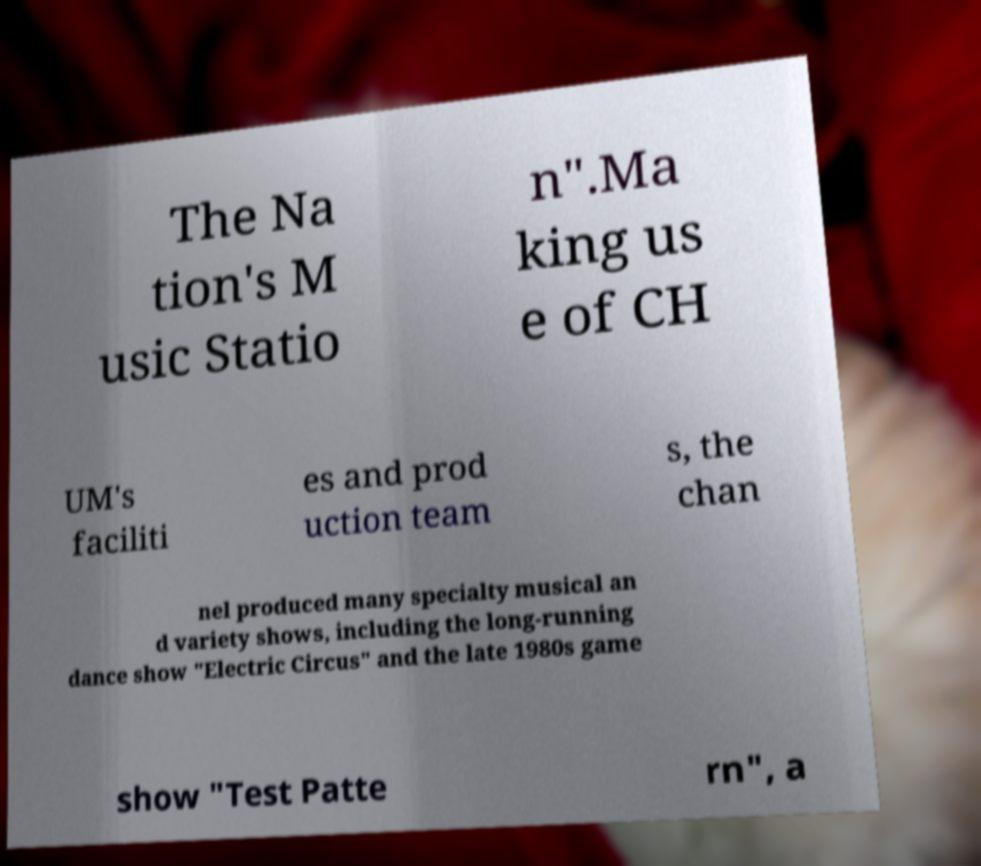There's text embedded in this image that I need extracted. Can you transcribe it verbatim? The Na tion's M usic Statio n".Ma king us e of CH UM's faciliti es and prod uction team s, the chan nel produced many specialty musical an d variety shows, including the long-running dance show "Electric Circus" and the late 1980s game show "Test Patte rn", a 